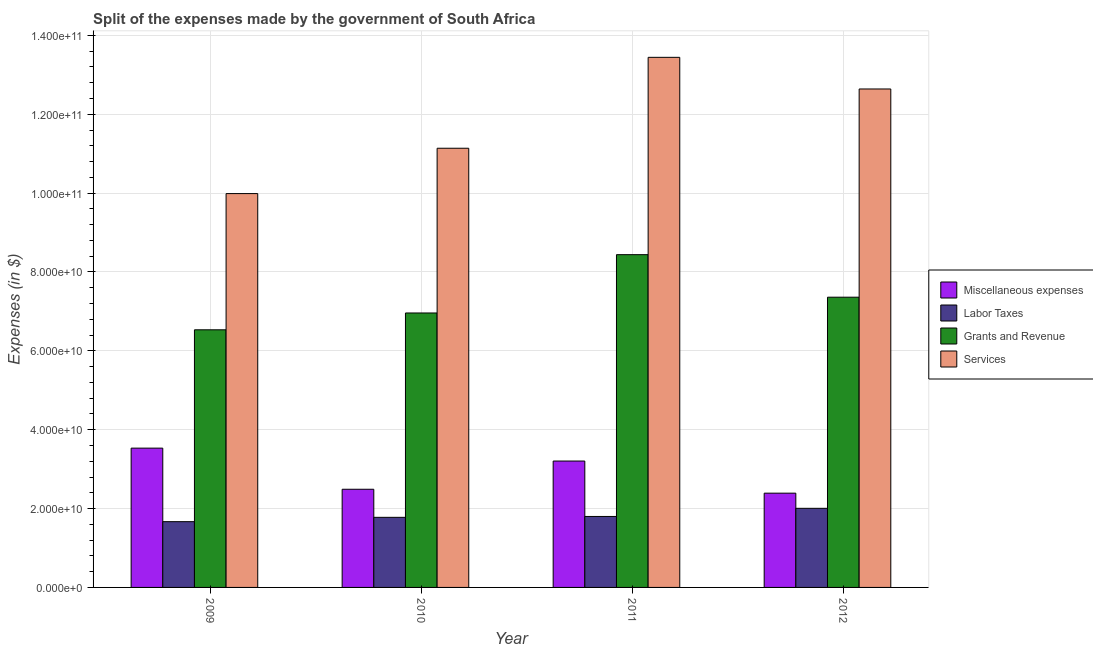How many different coloured bars are there?
Provide a succinct answer. 4. How many groups of bars are there?
Offer a terse response. 4. Are the number of bars on each tick of the X-axis equal?
Offer a very short reply. Yes. How many bars are there on the 4th tick from the left?
Your answer should be very brief. 4. What is the amount spent on grants and revenue in 2011?
Your response must be concise. 8.44e+1. Across all years, what is the maximum amount spent on labor taxes?
Offer a terse response. 2.01e+1. Across all years, what is the minimum amount spent on services?
Your response must be concise. 9.99e+1. In which year was the amount spent on grants and revenue minimum?
Give a very brief answer. 2009. What is the total amount spent on miscellaneous expenses in the graph?
Ensure brevity in your answer.  1.16e+11. What is the difference between the amount spent on labor taxes in 2009 and that in 2011?
Give a very brief answer. -1.32e+09. What is the difference between the amount spent on grants and revenue in 2010 and the amount spent on miscellaneous expenses in 2009?
Provide a short and direct response. 4.27e+09. What is the average amount spent on labor taxes per year?
Your answer should be very brief. 1.81e+1. In how many years, is the amount spent on services greater than 16000000000 $?
Provide a succinct answer. 4. What is the ratio of the amount spent on labor taxes in 2009 to that in 2010?
Offer a very short reply. 0.94. What is the difference between the highest and the second highest amount spent on labor taxes?
Ensure brevity in your answer.  2.07e+09. What is the difference between the highest and the lowest amount spent on services?
Ensure brevity in your answer.  3.46e+1. Is the sum of the amount spent on miscellaneous expenses in 2009 and 2012 greater than the maximum amount spent on grants and revenue across all years?
Ensure brevity in your answer.  Yes. What does the 1st bar from the left in 2012 represents?
Provide a short and direct response. Miscellaneous expenses. What does the 3rd bar from the right in 2011 represents?
Ensure brevity in your answer.  Labor Taxes. How many bars are there?
Provide a succinct answer. 16. How many years are there in the graph?
Your response must be concise. 4. What is the title of the graph?
Provide a short and direct response. Split of the expenses made by the government of South Africa. What is the label or title of the X-axis?
Your response must be concise. Year. What is the label or title of the Y-axis?
Ensure brevity in your answer.  Expenses (in $). What is the Expenses (in $) of Miscellaneous expenses in 2009?
Your answer should be very brief. 3.53e+1. What is the Expenses (in $) of Labor Taxes in 2009?
Give a very brief answer. 1.67e+1. What is the Expenses (in $) of Grants and Revenue in 2009?
Ensure brevity in your answer.  6.53e+1. What is the Expenses (in $) in Services in 2009?
Ensure brevity in your answer.  9.99e+1. What is the Expenses (in $) in Miscellaneous expenses in 2010?
Your response must be concise. 2.49e+1. What is the Expenses (in $) of Labor Taxes in 2010?
Your response must be concise. 1.78e+1. What is the Expenses (in $) in Grants and Revenue in 2010?
Your answer should be very brief. 6.96e+1. What is the Expenses (in $) in Services in 2010?
Keep it short and to the point. 1.11e+11. What is the Expenses (in $) in Miscellaneous expenses in 2011?
Offer a very short reply. 3.21e+1. What is the Expenses (in $) of Labor Taxes in 2011?
Keep it short and to the point. 1.80e+1. What is the Expenses (in $) in Grants and Revenue in 2011?
Make the answer very short. 8.44e+1. What is the Expenses (in $) in Services in 2011?
Offer a terse response. 1.34e+11. What is the Expenses (in $) in Miscellaneous expenses in 2012?
Your answer should be compact. 2.39e+1. What is the Expenses (in $) of Labor Taxes in 2012?
Offer a very short reply. 2.01e+1. What is the Expenses (in $) of Grants and Revenue in 2012?
Make the answer very short. 7.36e+1. What is the Expenses (in $) in Services in 2012?
Ensure brevity in your answer.  1.26e+11. Across all years, what is the maximum Expenses (in $) in Miscellaneous expenses?
Ensure brevity in your answer.  3.53e+1. Across all years, what is the maximum Expenses (in $) of Labor Taxes?
Offer a very short reply. 2.01e+1. Across all years, what is the maximum Expenses (in $) of Grants and Revenue?
Provide a short and direct response. 8.44e+1. Across all years, what is the maximum Expenses (in $) of Services?
Give a very brief answer. 1.34e+11. Across all years, what is the minimum Expenses (in $) in Miscellaneous expenses?
Keep it short and to the point. 2.39e+1. Across all years, what is the minimum Expenses (in $) in Labor Taxes?
Ensure brevity in your answer.  1.67e+1. Across all years, what is the minimum Expenses (in $) of Grants and Revenue?
Make the answer very short. 6.53e+1. Across all years, what is the minimum Expenses (in $) in Services?
Keep it short and to the point. 9.99e+1. What is the total Expenses (in $) in Miscellaneous expenses in the graph?
Keep it short and to the point. 1.16e+11. What is the total Expenses (in $) in Labor Taxes in the graph?
Your answer should be compact. 7.25e+1. What is the total Expenses (in $) in Grants and Revenue in the graph?
Offer a terse response. 2.93e+11. What is the total Expenses (in $) of Services in the graph?
Provide a short and direct response. 4.72e+11. What is the difference between the Expenses (in $) of Miscellaneous expenses in 2009 and that in 2010?
Your response must be concise. 1.04e+1. What is the difference between the Expenses (in $) in Labor Taxes in 2009 and that in 2010?
Give a very brief answer. -1.10e+09. What is the difference between the Expenses (in $) in Grants and Revenue in 2009 and that in 2010?
Your answer should be very brief. -4.27e+09. What is the difference between the Expenses (in $) of Services in 2009 and that in 2010?
Offer a terse response. -1.15e+1. What is the difference between the Expenses (in $) of Miscellaneous expenses in 2009 and that in 2011?
Keep it short and to the point. 3.27e+09. What is the difference between the Expenses (in $) in Labor Taxes in 2009 and that in 2011?
Your response must be concise. -1.32e+09. What is the difference between the Expenses (in $) of Grants and Revenue in 2009 and that in 2011?
Your answer should be compact. -1.91e+1. What is the difference between the Expenses (in $) in Services in 2009 and that in 2011?
Give a very brief answer. -3.46e+1. What is the difference between the Expenses (in $) in Miscellaneous expenses in 2009 and that in 2012?
Give a very brief answer. 1.14e+1. What is the difference between the Expenses (in $) in Labor Taxes in 2009 and that in 2012?
Make the answer very short. -3.39e+09. What is the difference between the Expenses (in $) of Grants and Revenue in 2009 and that in 2012?
Offer a very short reply. -8.27e+09. What is the difference between the Expenses (in $) in Services in 2009 and that in 2012?
Provide a short and direct response. -2.65e+1. What is the difference between the Expenses (in $) of Miscellaneous expenses in 2010 and that in 2011?
Ensure brevity in your answer.  -7.16e+09. What is the difference between the Expenses (in $) of Labor Taxes in 2010 and that in 2011?
Offer a terse response. -2.21e+08. What is the difference between the Expenses (in $) in Grants and Revenue in 2010 and that in 2011?
Offer a very short reply. -1.48e+1. What is the difference between the Expenses (in $) of Services in 2010 and that in 2011?
Provide a short and direct response. -2.31e+1. What is the difference between the Expenses (in $) of Miscellaneous expenses in 2010 and that in 2012?
Ensure brevity in your answer.  9.90e+08. What is the difference between the Expenses (in $) of Labor Taxes in 2010 and that in 2012?
Your response must be concise. -2.29e+09. What is the difference between the Expenses (in $) of Grants and Revenue in 2010 and that in 2012?
Ensure brevity in your answer.  -4.00e+09. What is the difference between the Expenses (in $) in Services in 2010 and that in 2012?
Keep it short and to the point. -1.50e+1. What is the difference between the Expenses (in $) in Miscellaneous expenses in 2011 and that in 2012?
Make the answer very short. 8.15e+09. What is the difference between the Expenses (in $) of Labor Taxes in 2011 and that in 2012?
Keep it short and to the point. -2.07e+09. What is the difference between the Expenses (in $) in Grants and Revenue in 2011 and that in 2012?
Provide a short and direct response. 1.08e+1. What is the difference between the Expenses (in $) of Services in 2011 and that in 2012?
Your response must be concise. 8.03e+09. What is the difference between the Expenses (in $) of Miscellaneous expenses in 2009 and the Expenses (in $) of Labor Taxes in 2010?
Offer a terse response. 1.75e+1. What is the difference between the Expenses (in $) of Miscellaneous expenses in 2009 and the Expenses (in $) of Grants and Revenue in 2010?
Offer a terse response. -3.43e+1. What is the difference between the Expenses (in $) of Miscellaneous expenses in 2009 and the Expenses (in $) of Services in 2010?
Give a very brief answer. -7.61e+1. What is the difference between the Expenses (in $) of Labor Taxes in 2009 and the Expenses (in $) of Grants and Revenue in 2010?
Offer a very short reply. -5.29e+1. What is the difference between the Expenses (in $) in Labor Taxes in 2009 and the Expenses (in $) in Services in 2010?
Provide a short and direct response. -9.47e+1. What is the difference between the Expenses (in $) in Grants and Revenue in 2009 and the Expenses (in $) in Services in 2010?
Your response must be concise. -4.60e+1. What is the difference between the Expenses (in $) of Miscellaneous expenses in 2009 and the Expenses (in $) of Labor Taxes in 2011?
Keep it short and to the point. 1.73e+1. What is the difference between the Expenses (in $) of Miscellaneous expenses in 2009 and the Expenses (in $) of Grants and Revenue in 2011?
Your answer should be very brief. -4.91e+1. What is the difference between the Expenses (in $) of Miscellaneous expenses in 2009 and the Expenses (in $) of Services in 2011?
Offer a terse response. -9.91e+1. What is the difference between the Expenses (in $) in Labor Taxes in 2009 and the Expenses (in $) in Grants and Revenue in 2011?
Make the answer very short. -6.77e+1. What is the difference between the Expenses (in $) of Labor Taxes in 2009 and the Expenses (in $) of Services in 2011?
Offer a terse response. -1.18e+11. What is the difference between the Expenses (in $) in Grants and Revenue in 2009 and the Expenses (in $) in Services in 2011?
Keep it short and to the point. -6.91e+1. What is the difference between the Expenses (in $) of Miscellaneous expenses in 2009 and the Expenses (in $) of Labor Taxes in 2012?
Provide a short and direct response. 1.53e+1. What is the difference between the Expenses (in $) in Miscellaneous expenses in 2009 and the Expenses (in $) in Grants and Revenue in 2012?
Give a very brief answer. -3.83e+1. What is the difference between the Expenses (in $) in Miscellaneous expenses in 2009 and the Expenses (in $) in Services in 2012?
Your answer should be very brief. -9.11e+1. What is the difference between the Expenses (in $) in Labor Taxes in 2009 and the Expenses (in $) in Grants and Revenue in 2012?
Offer a terse response. -5.69e+1. What is the difference between the Expenses (in $) in Labor Taxes in 2009 and the Expenses (in $) in Services in 2012?
Your answer should be compact. -1.10e+11. What is the difference between the Expenses (in $) in Grants and Revenue in 2009 and the Expenses (in $) in Services in 2012?
Give a very brief answer. -6.11e+1. What is the difference between the Expenses (in $) in Miscellaneous expenses in 2010 and the Expenses (in $) in Labor Taxes in 2011?
Offer a terse response. 6.90e+09. What is the difference between the Expenses (in $) of Miscellaneous expenses in 2010 and the Expenses (in $) of Grants and Revenue in 2011?
Provide a succinct answer. -5.95e+1. What is the difference between the Expenses (in $) in Miscellaneous expenses in 2010 and the Expenses (in $) in Services in 2011?
Offer a terse response. -1.10e+11. What is the difference between the Expenses (in $) of Labor Taxes in 2010 and the Expenses (in $) of Grants and Revenue in 2011?
Provide a short and direct response. -6.66e+1. What is the difference between the Expenses (in $) in Labor Taxes in 2010 and the Expenses (in $) in Services in 2011?
Keep it short and to the point. -1.17e+11. What is the difference between the Expenses (in $) of Grants and Revenue in 2010 and the Expenses (in $) of Services in 2011?
Ensure brevity in your answer.  -6.48e+1. What is the difference between the Expenses (in $) in Miscellaneous expenses in 2010 and the Expenses (in $) in Labor Taxes in 2012?
Keep it short and to the point. 4.83e+09. What is the difference between the Expenses (in $) of Miscellaneous expenses in 2010 and the Expenses (in $) of Grants and Revenue in 2012?
Offer a very short reply. -4.87e+1. What is the difference between the Expenses (in $) of Miscellaneous expenses in 2010 and the Expenses (in $) of Services in 2012?
Ensure brevity in your answer.  -1.02e+11. What is the difference between the Expenses (in $) in Labor Taxes in 2010 and the Expenses (in $) in Grants and Revenue in 2012?
Provide a succinct answer. -5.58e+1. What is the difference between the Expenses (in $) in Labor Taxes in 2010 and the Expenses (in $) in Services in 2012?
Provide a succinct answer. -1.09e+11. What is the difference between the Expenses (in $) in Grants and Revenue in 2010 and the Expenses (in $) in Services in 2012?
Offer a very short reply. -5.68e+1. What is the difference between the Expenses (in $) of Miscellaneous expenses in 2011 and the Expenses (in $) of Labor Taxes in 2012?
Your response must be concise. 1.20e+1. What is the difference between the Expenses (in $) in Miscellaneous expenses in 2011 and the Expenses (in $) in Grants and Revenue in 2012?
Your answer should be compact. -4.15e+1. What is the difference between the Expenses (in $) of Miscellaneous expenses in 2011 and the Expenses (in $) of Services in 2012?
Your answer should be very brief. -9.44e+1. What is the difference between the Expenses (in $) in Labor Taxes in 2011 and the Expenses (in $) in Grants and Revenue in 2012?
Offer a very short reply. -5.56e+1. What is the difference between the Expenses (in $) in Labor Taxes in 2011 and the Expenses (in $) in Services in 2012?
Make the answer very short. -1.08e+11. What is the difference between the Expenses (in $) in Grants and Revenue in 2011 and the Expenses (in $) in Services in 2012?
Offer a terse response. -4.20e+1. What is the average Expenses (in $) of Miscellaneous expenses per year?
Give a very brief answer. 2.90e+1. What is the average Expenses (in $) in Labor Taxes per year?
Your response must be concise. 1.81e+1. What is the average Expenses (in $) of Grants and Revenue per year?
Offer a terse response. 7.32e+1. What is the average Expenses (in $) of Services per year?
Give a very brief answer. 1.18e+11. In the year 2009, what is the difference between the Expenses (in $) of Miscellaneous expenses and Expenses (in $) of Labor Taxes?
Make the answer very short. 1.86e+1. In the year 2009, what is the difference between the Expenses (in $) of Miscellaneous expenses and Expenses (in $) of Grants and Revenue?
Your answer should be compact. -3.00e+1. In the year 2009, what is the difference between the Expenses (in $) of Miscellaneous expenses and Expenses (in $) of Services?
Make the answer very short. -6.46e+1. In the year 2009, what is the difference between the Expenses (in $) in Labor Taxes and Expenses (in $) in Grants and Revenue?
Provide a short and direct response. -4.87e+1. In the year 2009, what is the difference between the Expenses (in $) in Labor Taxes and Expenses (in $) in Services?
Provide a succinct answer. -8.32e+1. In the year 2009, what is the difference between the Expenses (in $) in Grants and Revenue and Expenses (in $) in Services?
Make the answer very short. -3.45e+1. In the year 2010, what is the difference between the Expenses (in $) of Miscellaneous expenses and Expenses (in $) of Labor Taxes?
Give a very brief answer. 7.12e+09. In the year 2010, what is the difference between the Expenses (in $) of Miscellaneous expenses and Expenses (in $) of Grants and Revenue?
Give a very brief answer. -4.47e+1. In the year 2010, what is the difference between the Expenses (in $) in Miscellaneous expenses and Expenses (in $) in Services?
Ensure brevity in your answer.  -8.65e+1. In the year 2010, what is the difference between the Expenses (in $) of Labor Taxes and Expenses (in $) of Grants and Revenue?
Keep it short and to the point. -5.18e+1. In the year 2010, what is the difference between the Expenses (in $) of Labor Taxes and Expenses (in $) of Services?
Ensure brevity in your answer.  -9.36e+1. In the year 2010, what is the difference between the Expenses (in $) in Grants and Revenue and Expenses (in $) in Services?
Your answer should be compact. -4.18e+1. In the year 2011, what is the difference between the Expenses (in $) in Miscellaneous expenses and Expenses (in $) in Labor Taxes?
Your response must be concise. 1.41e+1. In the year 2011, what is the difference between the Expenses (in $) of Miscellaneous expenses and Expenses (in $) of Grants and Revenue?
Your response must be concise. -5.23e+1. In the year 2011, what is the difference between the Expenses (in $) in Miscellaneous expenses and Expenses (in $) in Services?
Keep it short and to the point. -1.02e+11. In the year 2011, what is the difference between the Expenses (in $) in Labor Taxes and Expenses (in $) in Grants and Revenue?
Your answer should be very brief. -6.64e+1. In the year 2011, what is the difference between the Expenses (in $) in Labor Taxes and Expenses (in $) in Services?
Provide a succinct answer. -1.16e+11. In the year 2011, what is the difference between the Expenses (in $) of Grants and Revenue and Expenses (in $) of Services?
Provide a succinct answer. -5.00e+1. In the year 2012, what is the difference between the Expenses (in $) of Miscellaneous expenses and Expenses (in $) of Labor Taxes?
Give a very brief answer. 3.84e+09. In the year 2012, what is the difference between the Expenses (in $) in Miscellaneous expenses and Expenses (in $) in Grants and Revenue?
Your answer should be very brief. -4.97e+1. In the year 2012, what is the difference between the Expenses (in $) of Miscellaneous expenses and Expenses (in $) of Services?
Make the answer very short. -1.02e+11. In the year 2012, what is the difference between the Expenses (in $) of Labor Taxes and Expenses (in $) of Grants and Revenue?
Your response must be concise. -5.35e+1. In the year 2012, what is the difference between the Expenses (in $) in Labor Taxes and Expenses (in $) in Services?
Offer a terse response. -1.06e+11. In the year 2012, what is the difference between the Expenses (in $) of Grants and Revenue and Expenses (in $) of Services?
Provide a succinct answer. -5.28e+1. What is the ratio of the Expenses (in $) of Miscellaneous expenses in 2009 to that in 2010?
Ensure brevity in your answer.  1.42. What is the ratio of the Expenses (in $) of Labor Taxes in 2009 to that in 2010?
Ensure brevity in your answer.  0.94. What is the ratio of the Expenses (in $) in Grants and Revenue in 2009 to that in 2010?
Your response must be concise. 0.94. What is the ratio of the Expenses (in $) in Services in 2009 to that in 2010?
Make the answer very short. 0.9. What is the ratio of the Expenses (in $) of Miscellaneous expenses in 2009 to that in 2011?
Give a very brief answer. 1.1. What is the ratio of the Expenses (in $) of Labor Taxes in 2009 to that in 2011?
Make the answer very short. 0.93. What is the ratio of the Expenses (in $) in Grants and Revenue in 2009 to that in 2011?
Keep it short and to the point. 0.77. What is the ratio of the Expenses (in $) of Services in 2009 to that in 2011?
Your response must be concise. 0.74. What is the ratio of the Expenses (in $) of Miscellaneous expenses in 2009 to that in 2012?
Your response must be concise. 1.48. What is the ratio of the Expenses (in $) in Labor Taxes in 2009 to that in 2012?
Your answer should be very brief. 0.83. What is the ratio of the Expenses (in $) of Grants and Revenue in 2009 to that in 2012?
Make the answer very short. 0.89. What is the ratio of the Expenses (in $) in Services in 2009 to that in 2012?
Your answer should be very brief. 0.79. What is the ratio of the Expenses (in $) in Miscellaneous expenses in 2010 to that in 2011?
Offer a very short reply. 0.78. What is the ratio of the Expenses (in $) in Grants and Revenue in 2010 to that in 2011?
Keep it short and to the point. 0.82. What is the ratio of the Expenses (in $) in Services in 2010 to that in 2011?
Ensure brevity in your answer.  0.83. What is the ratio of the Expenses (in $) of Miscellaneous expenses in 2010 to that in 2012?
Offer a terse response. 1.04. What is the ratio of the Expenses (in $) of Labor Taxes in 2010 to that in 2012?
Offer a very short reply. 0.89. What is the ratio of the Expenses (in $) in Grants and Revenue in 2010 to that in 2012?
Offer a very short reply. 0.95. What is the ratio of the Expenses (in $) of Services in 2010 to that in 2012?
Give a very brief answer. 0.88. What is the ratio of the Expenses (in $) in Miscellaneous expenses in 2011 to that in 2012?
Your answer should be compact. 1.34. What is the ratio of the Expenses (in $) of Labor Taxes in 2011 to that in 2012?
Make the answer very short. 0.9. What is the ratio of the Expenses (in $) of Grants and Revenue in 2011 to that in 2012?
Give a very brief answer. 1.15. What is the ratio of the Expenses (in $) of Services in 2011 to that in 2012?
Keep it short and to the point. 1.06. What is the difference between the highest and the second highest Expenses (in $) in Miscellaneous expenses?
Keep it short and to the point. 3.27e+09. What is the difference between the highest and the second highest Expenses (in $) in Labor Taxes?
Keep it short and to the point. 2.07e+09. What is the difference between the highest and the second highest Expenses (in $) in Grants and Revenue?
Provide a succinct answer. 1.08e+1. What is the difference between the highest and the second highest Expenses (in $) of Services?
Provide a short and direct response. 8.03e+09. What is the difference between the highest and the lowest Expenses (in $) in Miscellaneous expenses?
Offer a very short reply. 1.14e+1. What is the difference between the highest and the lowest Expenses (in $) in Labor Taxes?
Give a very brief answer. 3.39e+09. What is the difference between the highest and the lowest Expenses (in $) of Grants and Revenue?
Offer a terse response. 1.91e+1. What is the difference between the highest and the lowest Expenses (in $) of Services?
Provide a short and direct response. 3.46e+1. 